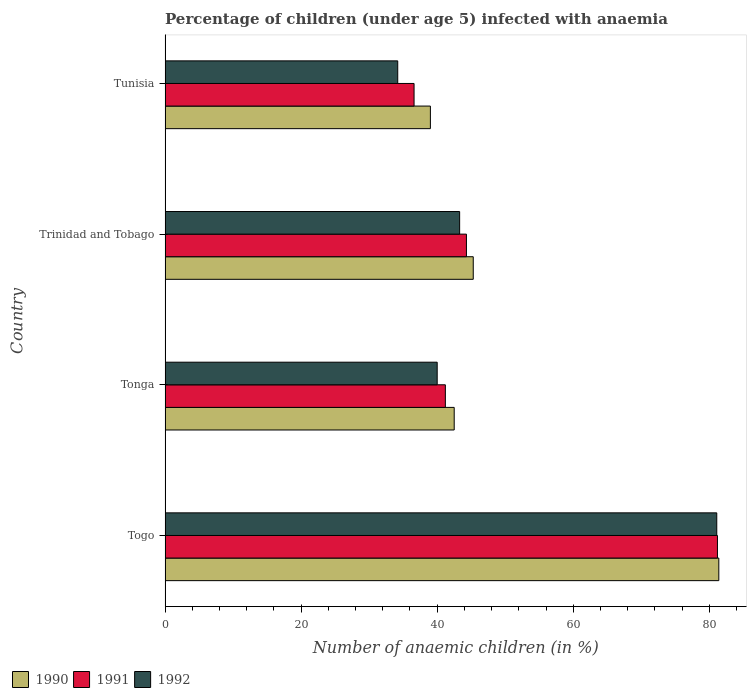How many different coloured bars are there?
Your answer should be compact. 3. How many groups of bars are there?
Offer a terse response. 4. Are the number of bars per tick equal to the number of legend labels?
Provide a short and direct response. Yes. What is the label of the 4th group of bars from the top?
Ensure brevity in your answer.  Togo. What is the percentage of children infected with anaemia in in 1990 in Tonga?
Your answer should be compact. 42.5. Across all countries, what is the maximum percentage of children infected with anaemia in in 1992?
Your answer should be compact. 81.1. Across all countries, what is the minimum percentage of children infected with anaemia in in 1992?
Offer a terse response. 34.2. In which country was the percentage of children infected with anaemia in in 1990 maximum?
Provide a short and direct response. Togo. In which country was the percentage of children infected with anaemia in in 1992 minimum?
Make the answer very short. Tunisia. What is the total percentage of children infected with anaemia in in 1991 in the graph?
Offer a very short reply. 203.3. What is the difference between the percentage of children infected with anaemia in in 1991 in Tonga and that in Trinidad and Tobago?
Provide a succinct answer. -3.1. What is the difference between the percentage of children infected with anaemia in in 1990 in Tunisia and the percentage of children infected with anaemia in in 1992 in Togo?
Keep it short and to the point. -42.1. What is the average percentage of children infected with anaemia in in 1990 per country?
Make the answer very short. 52.05. What is the ratio of the percentage of children infected with anaemia in in 1991 in Togo to that in Tunisia?
Your response must be concise. 2.22. Is the percentage of children infected with anaemia in in 1992 in Tonga less than that in Trinidad and Tobago?
Provide a short and direct response. Yes. Is the difference between the percentage of children infected with anaemia in in 1992 in Tonga and Tunisia greater than the difference between the percentage of children infected with anaemia in in 1990 in Tonga and Tunisia?
Offer a terse response. Yes. What is the difference between the highest and the second highest percentage of children infected with anaemia in in 1992?
Provide a succinct answer. 37.8. What is the difference between the highest and the lowest percentage of children infected with anaemia in in 1990?
Keep it short and to the point. 42.4. Is the sum of the percentage of children infected with anaemia in in 1992 in Togo and Tunisia greater than the maximum percentage of children infected with anaemia in in 1990 across all countries?
Give a very brief answer. Yes. What does the 2nd bar from the bottom in Tunisia represents?
Your answer should be compact. 1991. How many bars are there?
Make the answer very short. 12. How many countries are there in the graph?
Your answer should be very brief. 4. Are the values on the major ticks of X-axis written in scientific E-notation?
Your answer should be compact. No. Does the graph contain grids?
Provide a short and direct response. No. What is the title of the graph?
Your response must be concise. Percentage of children (under age 5) infected with anaemia. Does "2010" appear as one of the legend labels in the graph?
Ensure brevity in your answer.  No. What is the label or title of the X-axis?
Make the answer very short. Number of anaemic children (in %). What is the Number of anaemic children (in %) of 1990 in Togo?
Your answer should be compact. 81.4. What is the Number of anaemic children (in %) in 1991 in Togo?
Offer a terse response. 81.2. What is the Number of anaemic children (in %) of 1992 in Togo?
Ensure brevity in your answer.  81.1. What is the Number of anaemic children (in %) of 1990 in Tonga?
Make the answer very short. 42.5. What is the Number of anaemic children (in %) in 1991 in Tonga?
Keep it short and to the point. 41.2. What is the Number of anaemic children (in %) of 1992 in Tonga?
Provide a succinct answer. 40. What is the Number of anaemic children (in %) of 1990 in Trinidad and Tobago?
Your response must be concise. 45.3. What is the Number of anaemic children (in %) in 1991 in Trinidad and Tobago?
Give a very brief answer. 44.3. What is the Number of anaemic children (in %) of 1992 in Trinidad and Tobago?
Offer a very short reply. 43.3. What is the Number of anaemic children (in %) of 1991 in Tunisia?
Offer a terse response. 36.6. What is the Number of anaemic children (in %) in 1992 in Tunisia?
Your answer should be very brief. 34.2. Across all countries, what is the maximum Number of anaemic children (in %) in 1990?
Offer a very short reply. 81.4. Across all countries, what is the maximum Number of anaemic children (in %) in 1991?
Your answer should be compact. 81.2. Across all countries, what is the maximum Number of anaemic children (in %) in 1992?
Keep it short and to the point. 81.1. Across all countries, what is the minimum Number of anaemic children (in %) of 1990?
Provide a succinct answer. 39. Across all countries, what is the minimum Number of anaemic children (in %) in 1991?
Offer a terse response. 36.6. Across all countries, what is the minimum Number of anaemic children (in %) in 1992?
Provide a succinct answer. 34.2. What is the total Number of anaemic children (in %) of 1990 in the graph?
Make the answer very short. 208.2. What is the total Number of anaemic children (in %) of 1991 in the graph?
Provide a succinct answer. 203.3. What is the total Number of anaemic children (in %) of 1992 in the graph?
Provide a succinct answer. 198.6. What is the difference between the Number of anaemic children (in %) of 1990 in Togo and that in Tonga?
Offer a terse response. 38.9. What is the difference between the Number of anaemic children (in %) of 1991 in Togo and that in Tonga?
Keep it short and to the point. 40. What is the difference between the Number of anaemic children (in %) of 1992 in Togo and that in Tonga?
Offer a very short reply. 41.1. What is the difference between the Number of anaemic children (in %) in 1990 in Togo and that in Trinidad and Tobago?
Offer a terse response. 36.1. What is the difference between the Number of anaemic children (in %) in 1991 in Togo and that in Trinidad and Tobago?
Make the answer very short. 36.9. What is the difference between the Number of anaemic children (in %) of 1992 in Togo and that in Trinidad and Tobago?
Offer a terse response. 37.8. What is the difference between the Number of anaemic children (in %) in 1990 in Togo and that in Tunisia?
Keep it short and to the point. 42.4. What is the difference between the Number of anaemic children (in %) of 1991 in Togo and that in Tunisia?
Provide a succinct answer. 44.6. What is the difference between the Number of anaemic children (in %) in 1992 in Togo and that in Tunisia?
Your answer should be very brief. 46.9. What is the difference between the Number of anaemic children (in %) in 1991 in Tonga and that in Trinidad and Tobago?
Make the answer very short. -3.1. What is the difference between the Number of anaemic children (in %) of 1992 in Tonga and that in Trinidad and Tobago?
Ensure brevity in your answer.  -3.3. What is the difference between the Number of anaemic children (in %) of 1990 in Tonga and that in Tunisia?
Offer a terse response. 3.5. What is the difference between the Number of anaemic children (in %) of 1990 in Trinidad and Tobago and that in Tunisia?
Your response must be concise. 6.3. What is the difference between the Number of anaemic children (in %) of 1992 in Trinidad and Tobago and that in Tunisia?
Offer a very short reply. 9.1. What is the difference between the Number of anaemic children (in %) in 1990 in Togo and the Number of anaemic children (in %) in 1991 in Tonga?
Your response must be concise. 40.2. What is the difference between the Number of anaemic children (in %) in 1990 in Togo and the Number of anaemic children (in %) in 1992 in Tonga?
Give a very brief answer. 41.4. What is the difference between the Number of anaemic children (in %) in 1991 in Togo and the Number of anaemic children (in %) in 1992 in Tonga?
Make the answer very short. 41.2. What is the difference between the Number of anaemic children (in %) of 1990 in Togo and the Number of anaemic children (in %) of 1991 in Trinidad and Tobago?
Give a very brief answer. 37.1. What is the difference between the Number of anaemic children (in %) of 1990 in Togo and the Number of anaemic children (in %) of 1992 in Trinidad and Tobago?
Your answer should be very brief. 38.1. What is the difference between the Number of anaemic children (in %) of 1991 in Togo and the Number of anaemic children (in %) of 1992 in Trinidad and Tobago?
Provide a succinct answer. 37.9. What is the difference between the Number of anaemic children (in %) of 1990 in Togo and the Number of anaemic children (in %) of 1991 in Tunisia?
Give a very brief answer. 44.8. What is the difference between the Number of anaemic children (in %) of 1990 in Togo and the Number of anaemic children (in %) of 1992 in Tunisia?
Provide a short and direct response. 47.2. What is the difference between the Number of anaemic children (in %) in 1991 in Togo and the Number of anaemic children (in %) in 1992 in Tunisia?
Your answer should be very brief. 47. What is the difference between the Number of anaemic children (in %) in 1990 in Tonga and the Number of anaemic children (in %) in 1992 in Trinidad and Tobago?
Your response must be concise. -0.8. What is the difference between the Number of anaemic children (in %) of 1990 in Tonga and the Number of anaemic children (in %) of 1991 in Tunisia?
Your answer should be very brief. 5.9. What is the difference between the Number of anaemic children (in %) in 1990 in Tonga and the Number of anaemic children (in %) in 1992 in Tunisia?
Your answer should be very brief. 8.3. What is the difference between the Number of anaemic children (in %) of 1991 in Tonga and the Number of anaemic children (in %) of 1992 in Tunisia?
Make the answer very short. 7. What is the difference between the Number of anaemic children (in %) of 1990 in Trinidad and Tobago and the Number of anaemic children (in %) of 1991 in Tunisia?
Offer a very short reply. 8.7. What is the difference between the Number of anaemic children (in %) in 1991 in Trinidad and Tobago and the Number of anaemic children (in %) in 1992 in Tunisia?
Make the answer very short. 10.1. What is the average Number of anaemic children (in %) in 1990 per country?
Ensure brevity in your answer.  52.05. What is the average Number of anaemic children (in %) in 1991 per country?
Your answer should be very brief. 50.83. What is the average Number of anaemic children (in %) of 1992 per country?
Keep it short and to the point. 49.65. What is the difference between the Number of anaemic children (in %) in 1990 and Number of anaemic children (in %) in 1991 in Togo?
Your answer should be very brief. 0.2. What is the difference between the Number of anaemic children (in %) in 1990 and Number of anaemic children (in %) in 1992 in Tonga?
Your answer should be compact. 2.5. What is the difference between the Number of anaemic children (in %) in 1991 and Number of anaemic children (in %) in 1992 in Trinidad and Tobago?
Provide a short and direct response. 1. What is the difference between the Number of anaemic children (in %) of 1991 and Number of anaemic children (in %) of 1992 in Tunisia?
Ensure brevity in your answer.  2.4. What is the ratio of the Number of anaemic children (in %) of 1990 in Togo to that in Tonga?
Your answer should be very brief. 1.92. What is the ratio of the Number of anaemic children (in %) in 1991 in Togo to that in Tonga?
Make the answer very short. 1.97. What is the ratio of the Number of anaemic children (in %) in 1992 in Togo to that in Tonga?
Your answer should be compact. 2.03. What is the ratio of the Number of anaemic children (in %) in 1990 in Togo to that in Trinidad and Tobago?
Keep it short and to the point. 1.8. What is the ratio of the Number of anaemic children (in %) of 1991 in Togo to that in Trinidad and Tobago?
Make the answer very short. 1.83. What is the ratio of the Number of anaemic children (in %) of 1992 in Togo to that in Trinidad and Tobago?
Your answer should be very brief. 1.87. What is the ratio of the Number of anaemic children (in %) of 1990 in Togo to that in Tunisia?
Make the answer very short. 2.09. What is the ratio of the Number of anaemic children (in %) of 1991 in Togo to that in Tunisia?
Offer a very short reply. 2.22. What is the ratio of the Number of anaemic children (in %) in 1992 in Togo to that in Tunisia?
Provide a succinct answer. 2.37. What is the ratio of the Number of anaemic children (in %) of 1990 in Tonga to that in Trinidad and Tobago?
Provide a succinct answer. 0.94. What is the ratio of the Number of anaemic children (in %) of 1991 in Tonga to that in Trinidad and Tobago?
Provide a short and direct response. 0.93. What is the ratio of the Number of anaemic children (in %) of 1992 in Tonga to that in Trinidad and Tobago?
Your response must be concise. 0.92. What is the ratio of the Number of anaemic children (in %) of 1990 in Tonga to that in Tunisia?
Give a very brief answer. 1.09. What is the ratio of the Number of anaemic children (in %) in 1991 in Tonga to that in Tunisia?
Keep it short and to the point. 1.13. What is the ratio of the Number of anaemic children (in %) in 1992 in Tonga to that in Tunisia?
Your answer should be very brief. 1.17. What is the ratio of the Number of anaemic children (in %) of 1990 in Trinidad and Tobago to that in Tunisia?
Keep it short and to the point. 1.16. What is the ratio of the Number of anaemic children (in %) in 1991 in Trinidad and Tobago to that in Tunisia?
Give a very brief answer. 1.21. What is the ratio of the Number of anaemic children (in %) in 1992 in Trinidad and Tobago to that in Tunisia?
Your answer should be compact. 1.27. What is the difference between the highest and the second highest Number of anaemic children (in %) of 1990?
Offer a terse response. 36.1. What is the difference between the highest and the second highest Number of anaemic children (in %) of 1991?
Offer a very short reply. 36.9. What is the difference between the highest and the second highest Number of anaemic children (in %) of 1992?
Keep it short and to the point. 37.8. What is the difference between the highest and the lowest Number of anaemic children (in %) of 1990?
Ensure brevity in your answer.  42.4. What is the difference between the highest and the lowest Number of anaemic children (in %) of 1991?
Your response must be concise. 44.6. What is the difference between the highest and the lowest Number of anaemic children (in %) of 1992?
Your answer should be compact. 46.9. 